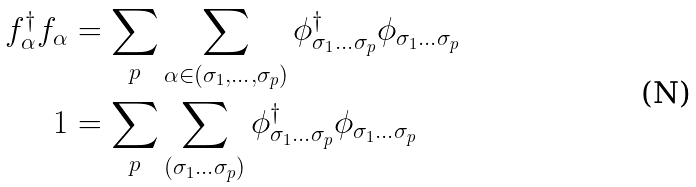Convert formula to latex. <formula><loc_0><loc_0><loc_500><loc_500>f ^ { \dagger } _ { \alpha } f _ { \alpha } & = \sum _ { p } \sum _ { \alpha \in ( \sigma _ { 1 } , \dots , \sigma _ { p } ) } \phi ^ { \dagger } _ { \sigma _ { 1 } \dots \sigma _ { p } } \phi _ { \sigma _ { 1 } \dots \sigma _ { p } } \\ 1 & = \sum _ { p } \sum _ { ( \sigma _ { 1 } \dots \sigma _ { p } ) } \phi ^ { \dagger } _ { \sigma _ { 1 } \dots \sigma _ { p } } \phi _ { \sigma _ { 1 } \dots \sigma _ { p } }</formula> 